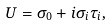Convert formula to latex. <formula><loc_0><loc_0><loc_500><loc_500>U = \sigma _ { 0 } + i \sigma _ { i } \tau _ { i } ,</formula> 